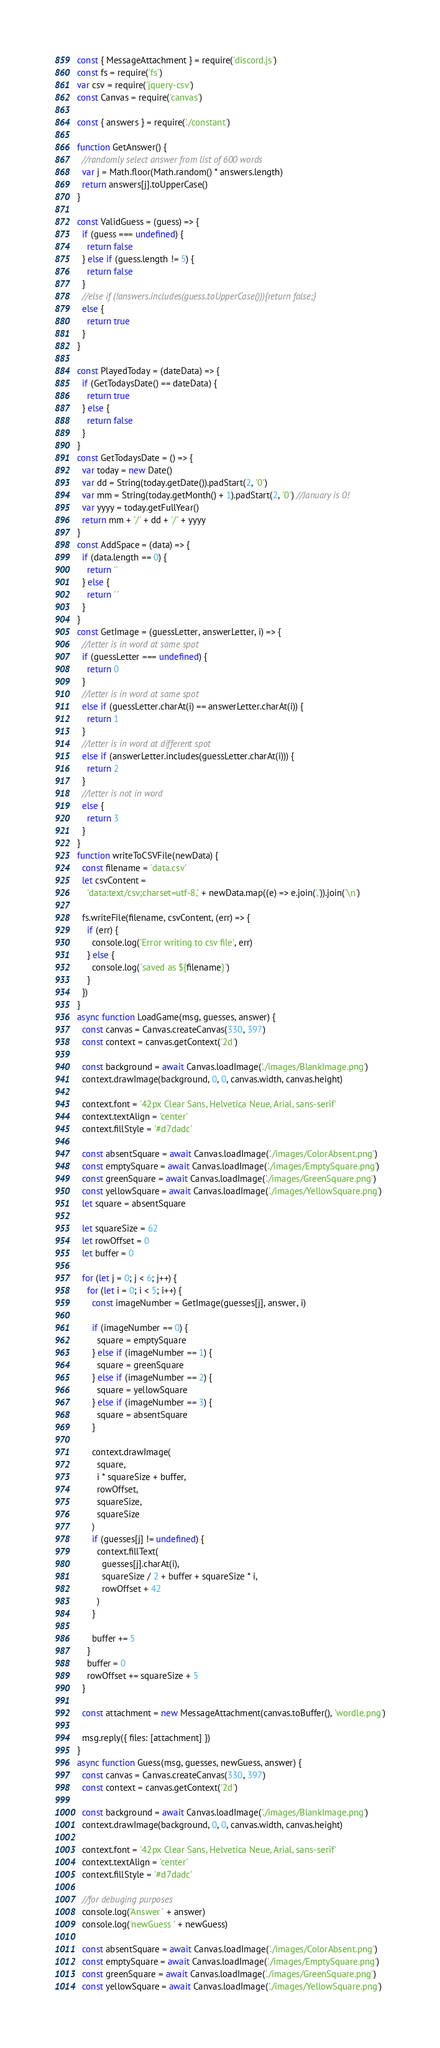<code> <loc_0><loc_0><loc_500><loc_500><_JavaScript_>const { MessageAttachment } = require('discord.js')
const fs = require('fs')
var csv = require('jquery-csv')
const Canvas = require('canvas')

const { answers } = require('./constant')

function GetAnswer() {
  //randomly select answer from list of 600 words
  var j = Math.floor(Math.random() * answers.length)
  return answers[j].toUpperCase()
}

const ValidGuess = (guess) => {
  if (guess === undefined) {
    return false
  } else if (guess.length != 5) {
    return false
  }
  //else if (!answers.includes(guess.toUpperCase())){return false;}
  else {
    return true
  }
}

const PlayedToday = (dateData) => {
  if (GetTodaysDate() == dateData) {
    return true
  } else {
    return false
  }
}
const GetTodaysDate = () => {
  var today = new Date()
  var dd = String(today.getDate()).padStart(2, '0')
  var mm = String(today.getMonth() + 1).padStart(2, '0') //January is 0!
  var yyyy = today.getFullYear()
  return mm + '/' + dd + '/' + yyyy
}
const AddSpace = (data) => {
  if (data.length == 0) {
    return ''
  } else {
    return ' '
  }
}
const GetImage = (guessLetter, answerLetter, i) => {
  //letter is in word at same spot
  if (guessLetter === undefined) {
    return 0
  }
  //letter is in word at same spot
  else if (guessLetter.charAt(i) == answerLetter.charAt(i)) {
    return 1
  }
  //letter is in word at different spot
  else if (answerLetter.includes(guessLetter.charAt(i))) {
    return 2
  }
  //letter is not in word
  else {
    return 3
  }
}
function writeToCSVFile(newData) {
  const filename = 'data.csv'
  let csvContent =
    'data:text/csv;charset=utf-8,' + newData.map((e) => e.join(',')).join('\n')

  fs.writeFile(filename, csvContent, (err) => {
    if (err) {
      console.log('Error writing to csv file', err)
    } else {
      console.log(`saved as ${filename}`)
    }
  })
}
async function LoadGame(msg, guesses, answer) {
  const canvas = Canvas.createCanvas(330, 397)
  const context = canvas.getContext('2d')

  const background = await Canvas.loadImage('./images/BlankImage.png')
  context.drawImage(background, 0, 0, canvas.width, canvas.height)

  context.font = '42px Clear Sans, Helvetica Neue, Arial, sans-serif'
  context.textAlign = 'center'
  context.fillStyle = '#d7dadc'

  const absentSquare = await Canvas.loadImage('./images/ColorAbsent.png')
  const emptySquare = await Canvas.loadImage('./images/EmptySquare.png')
  const greenSquare = await Canvas.loadImage('./images/GreenSquare.png')
  const yellowSquare = await Canvas.loadImage('./images/YellowSquare.png')
  let square = absentSquare

  let squareSize = 62
  let rowOffset = 0
  let buffer = 0

  for (let j = 0; j < 6; j++) {
    for (let i = 0; i < 5; i++) {
      const imageNumber = GetImage(guesses[j], answer, i)

      if (imageNumber == 0) {
        square = emptySquare
      } else if (imageNumber == 1) {
        square = greenSquare
      } else if (imageNumber == 2) {
        square = yellowSquare
      } else if (imageNumber == 3) {
        square = absentSquare
      }

      context.drawImage(
        square,
        i * squareSize + buffer,
        rowOffset,
        squareSize,
        squareSize
      )
      if (guesses[j] != undefined) {
        context.fillText(
          guesses[j].charAt(i),
          squareSize / 2 + buffer + squareSize * i,
          rowOffset + 42
        )
      }

      buffer += 5
    }
    buffer = 0
    rowOffset += squareSize + 5
  }

  const attachment = new MessageAttachment(canvas.toBuffer(), 'wordle.png')

  msg.reply({ files: [attachment] })
}
async function Guess(msg, guesses, newGuess, answer) {
  const canvas = Canvas.createCanvas(330, 397)
  const context = canvas.getContext('2d')

  const background = await Canvas.loadImage('./images/BlankImage.png')
  context.drawImage(background, 0, 0, canvas.width, canvas.height)

  context.font = '42px Clear Sans, Helvetica Neue, Arial, sans-serif'
  context.textAlign = 'center'
  context.fillStyle = '#d7dadc'

  //for debuging purposes
  console.log('Answer ' + answer)
  console.log('newGuess ' + newGuess)

  const absentSquare = await Canvas.loadImage('./images/ColorAbsent.png')
  const emptySquare = await Canvas.loadImage('./images/EmptySquare.png')
  const greenSquare = await Canvas.loadImage('./images/GreenSquare.png')
  const yellowSquare = await Canvas.loadImage('./images/YellowSquare.png')</code> 